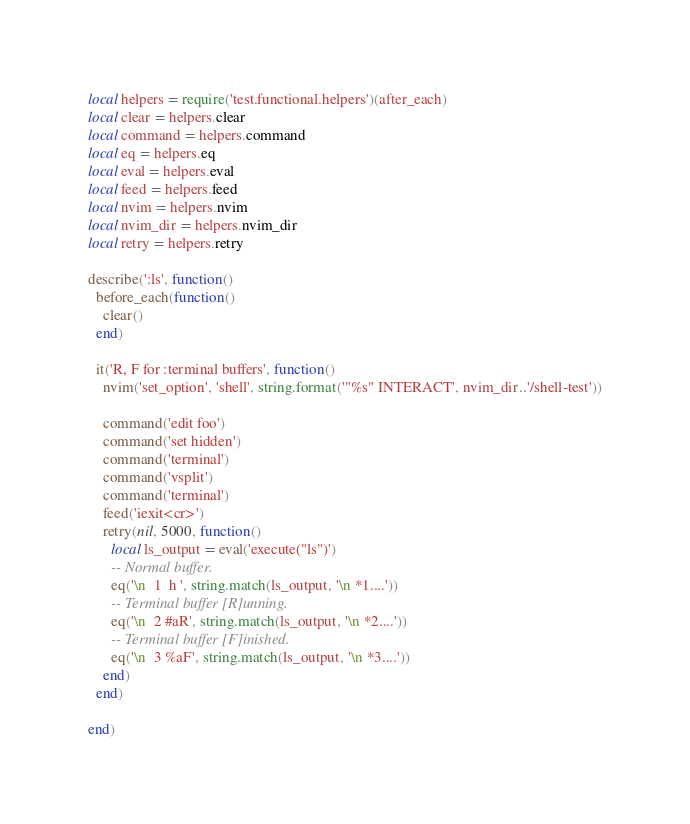<code> <loc_0><loc_0><loc_500><loc_500><_Lua_>local helpers = require('test.functional.helpers')(after_each)
local clear = helpers.clear
local command = helpers.command
local eq = helpers.eq
local eval = helpers.eval
local feed = helpers.feed
local nvim = helpers.nvim
local nvim_dir = helpers.nvim_dir
local retry = helpers.retry

describe(':ls', function()
  before_each(function()
    clear()
  end)

  it('R, F for :terminal buffers', function()
    nvim('set_option', 'shell', string.format('"%s" INTERACT', nvim_dir..'/shell-test'))

    command('edit foo')
    command('set hidden')
    command('terminal')
    command('vsplit')
    command('terminal')
    feed('iexit<cr>')
    retry(nil, 5000, function()
      local ls_output = eval('execute("ls")')
      -- Normal buffer.
      eq('\n  1  h ', string.match(ls_output, '\n *1....'))
      -- Terminal buffer [R]unning.
      eq('\n  2 #aR', string.match(ls_output, '\n *2....'))
      -- Terminal buffer [F]inished.
      eq('\n  3 %aF', string.match(ls_output, '\n *3....'))
    end)
  end)

end)

</code> 